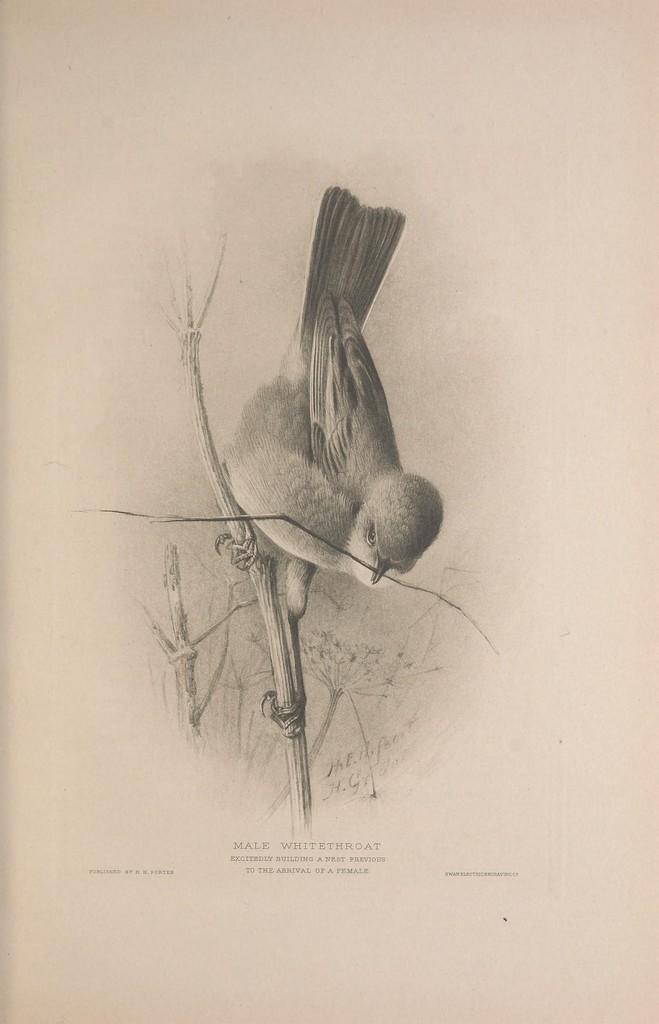Please provide a concise description of this image. In the picture we can see a sketch drawing of a bird which is standing on the stem holding it. 